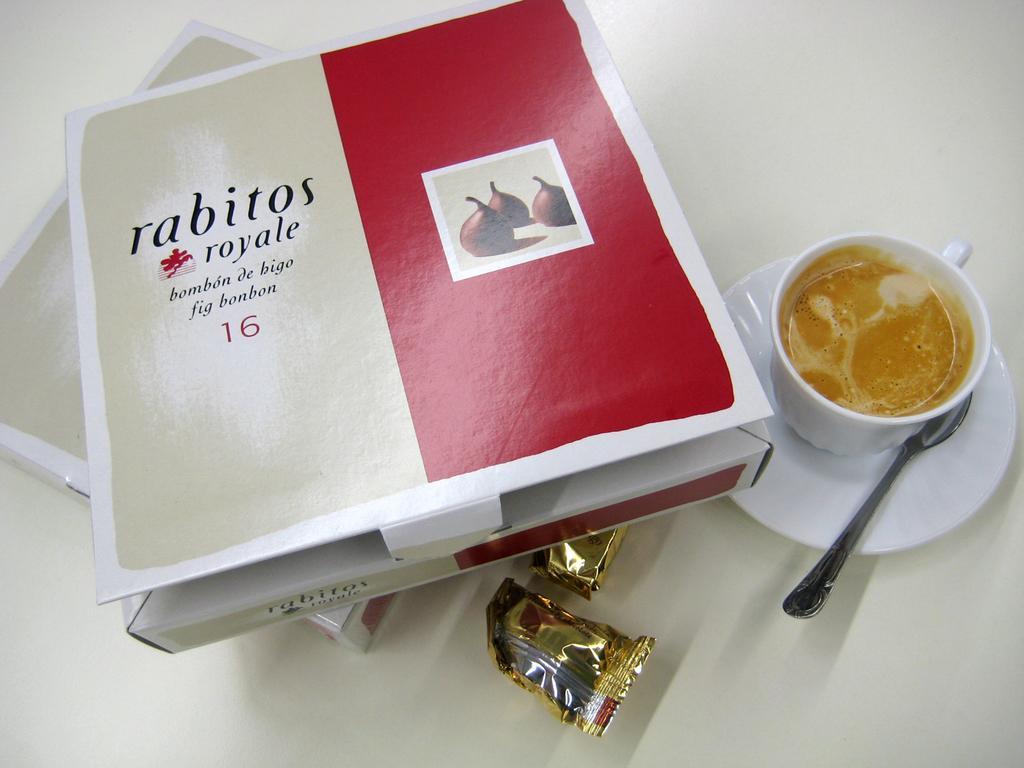Please provide a concise description of this image. In this image we can see two boxes on a surface. On the boxes we can see the text and image. Beside the boxes there is a cup and a spoon on the saucer. In the cup we can see the drink. 